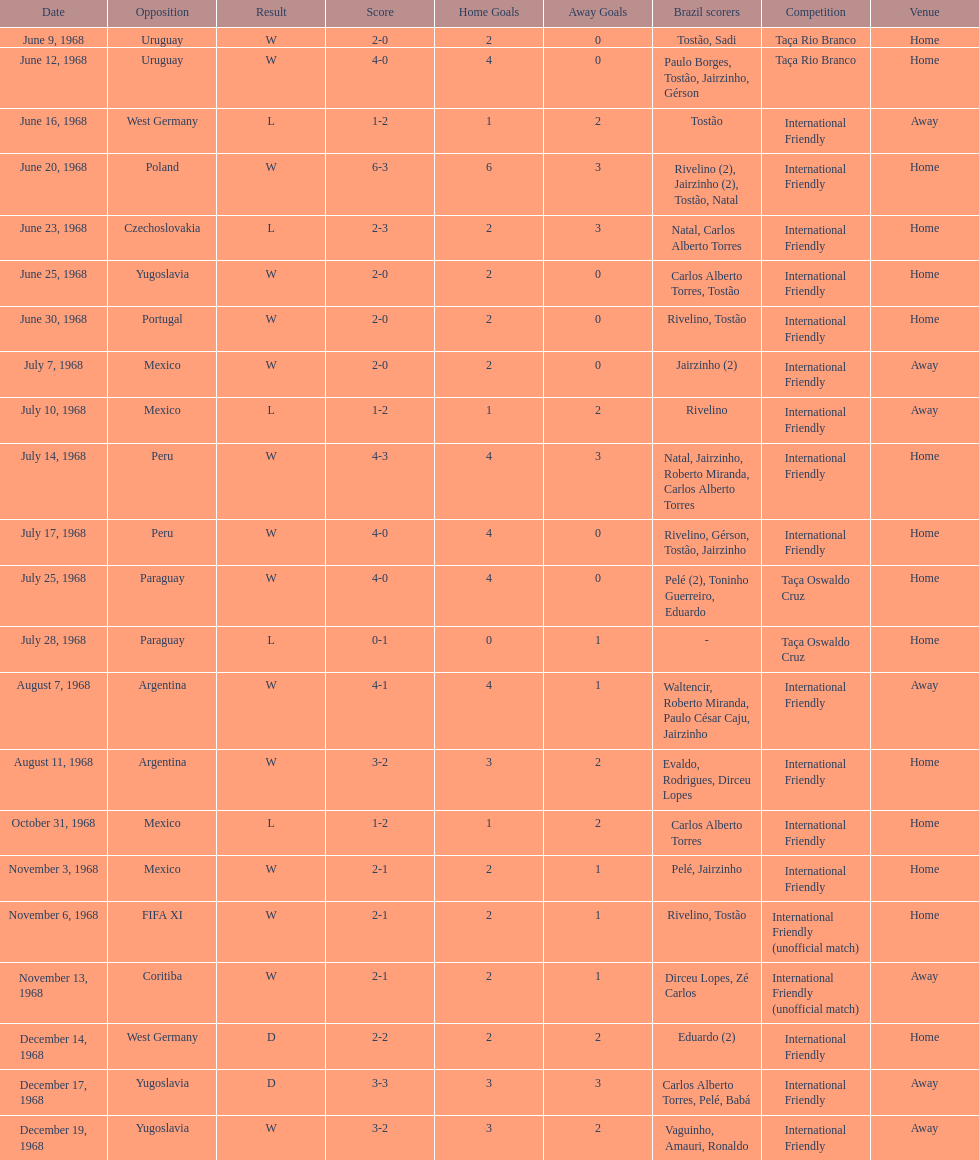How many times did brazil score during the game on november 6th? 2. 